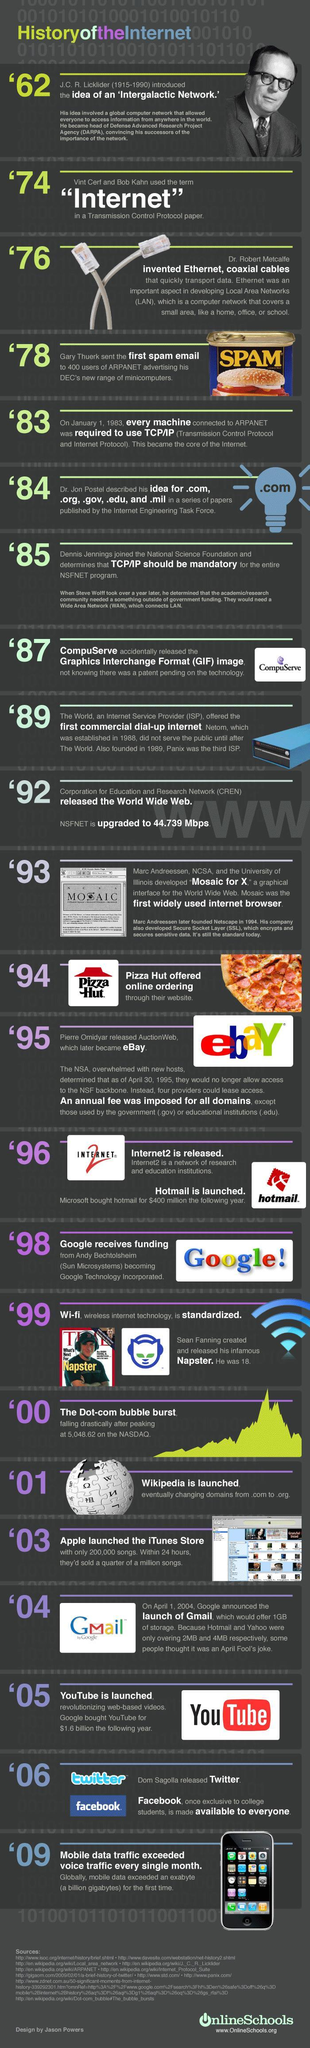What is written on the canned food?
Answer the question with a short phrase. SPAM Which was the first browser, Google, Internet 2, or Mosaic? Mosaic Which are two email service providers mentioned? GMail, hotmail When was the concept of internet conceived, 1974, 1962, or 1983? 1962 Which company name is mentioned in the logo having an image of a red hat? Pizza Hut Which year is considered to be the genesis of the .com, 1983, 1984, or 2000? 1984 